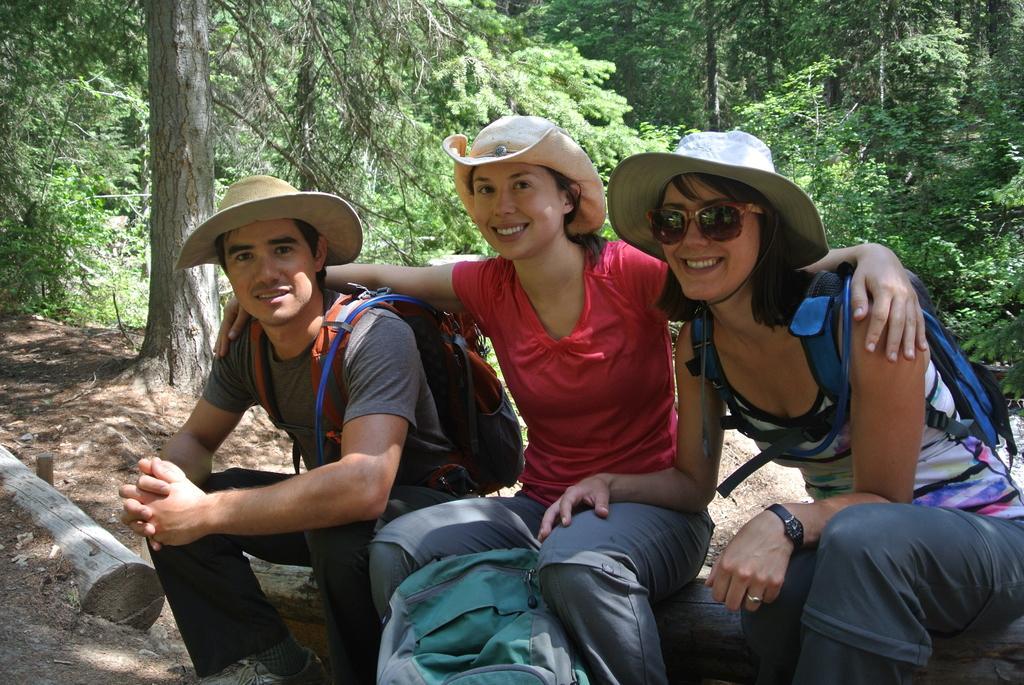Could you give a brief overview of what you see in this image? In this picture we can see bags, three people wore hats, sitting on a wooden log and smiling. In the background we can see trees. 